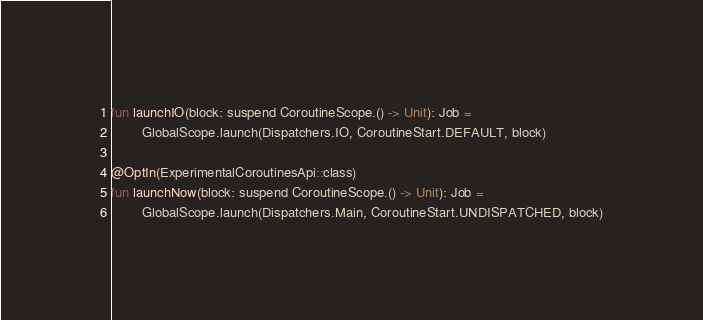Convert code to text. <code><loc_0><loc_0><loc_500><loc_500><_Kotlin_>fun launchIO(block: suspend CoroutineScope.() -> Unit): Job =
        GlobalScope.launch(Dispatchers.IO, CoroutineStart.DEFAULT, block)

@OptIn(ExperimentalCoroutinesApi::class)
fun launchNow(block: suspend CoroutineScope.() -> Unit): Job =
        GlobalScope.launch(Dispatchers.Main, CoroutineStart.UNDISPATCHED, block)
</code> 